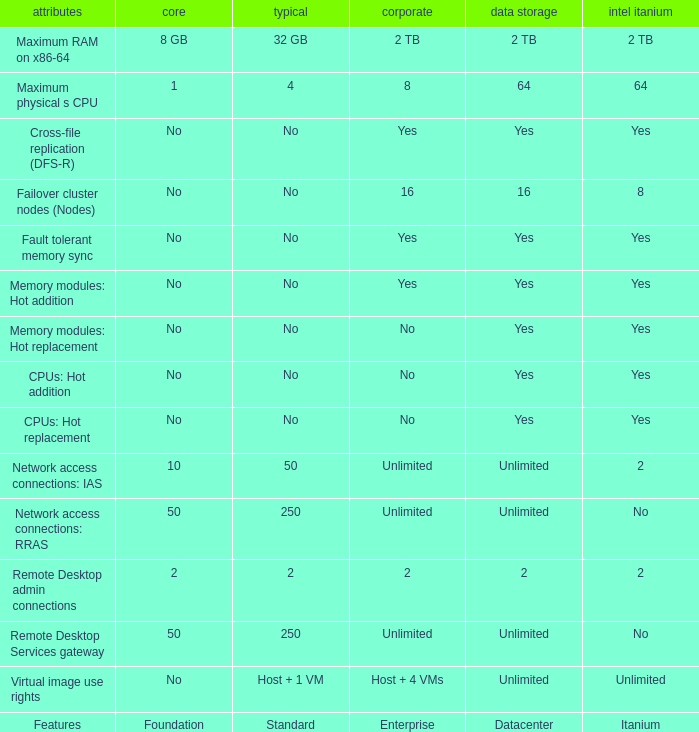Which Foundation has an Enterprise of 2? 2.0. 